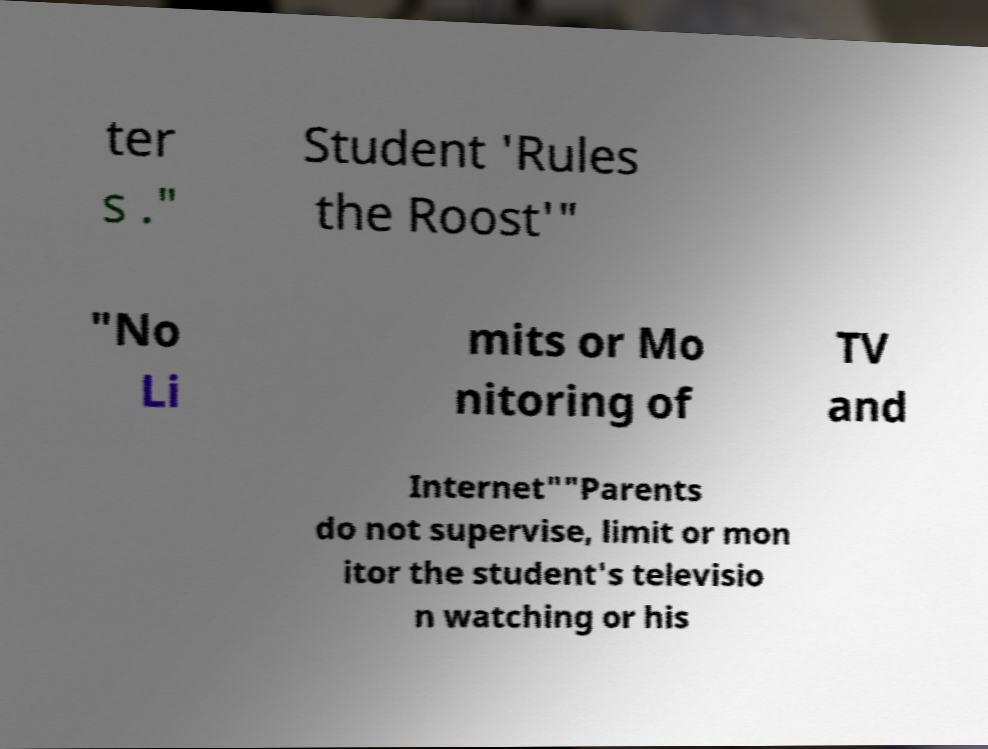I need the written content from this picture converted into text. Can you do that? ter s ." Student 'Rules the Roost'" "No Li mits or Mo nitoring of TV and Internet""Parents do not supervise, limit or mon itor the student's televisio n watching or his 